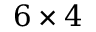<formula> <loc_0><loc_0><loc_500><loc_500>6 \times 4</formula> 